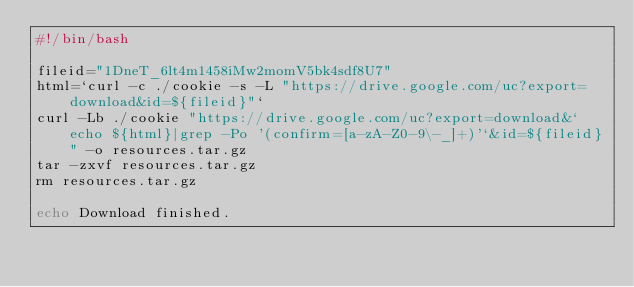Convert code to text. <code><loc_0><loc_0><loc_500><loc_500><_Bash_>#!/bin/bash

fileid="1DneT_6lt4m1458iMw2momV5bk4sdf8U7"
html=`curl -c ./cookie -s -L "https://drive.google.com/uc?export=download&id=${fileid}"`
curl -Lb ./cookie "https://drive.google.com/uc?export=download&`echo ${html}|grep -Po '(confirm=[a-zA-Z0-9\-_]+)'`&id=${fileid}" -o resources.tar.gz
tar -zxvf resources.tar.gz
rm resources.tar.gz

echo Download finished.
</code> 